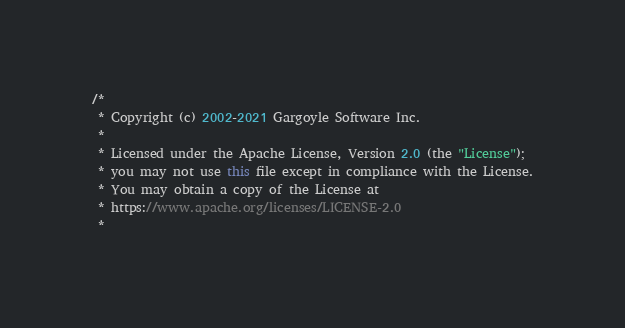Convert code to text. <code><loc_0><loc_0><loc_500><loc_500><_Java_>/*
 * Copyright (c) 2002-2021 Gargoyle Software Inc.
 *
 * Licensed under the Apache License, Version 2.0 (the "License");
 * you may not use this file except in compliance with the License.
 * You may obtain a copy of the License at
 * https://www.apache.org/licenses/LICENSE-2.0
 *</code> 